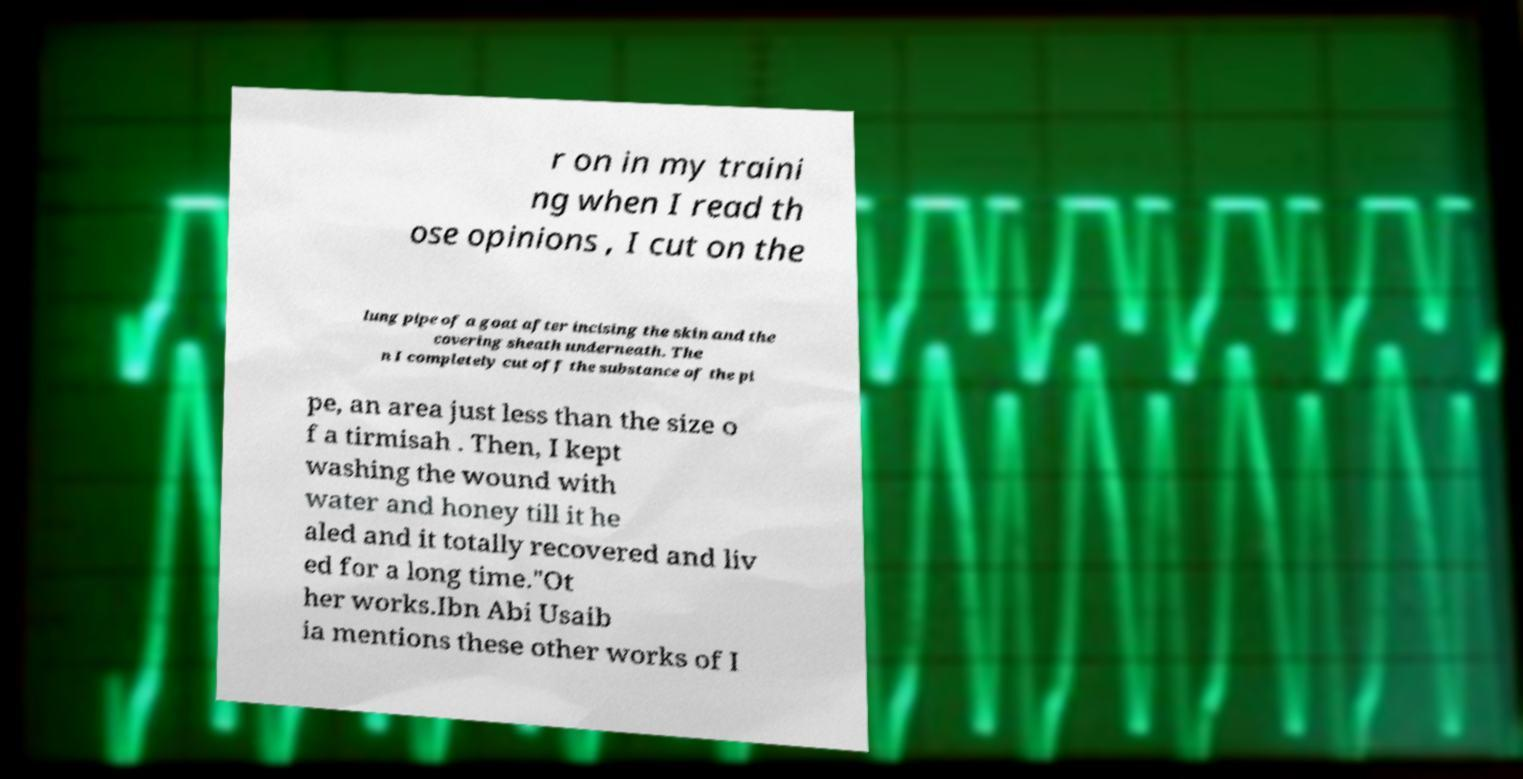Please read and relay the text visible in this image. What does it say? r on in my traini ng when I read th ose opinions , I cut on the lung pipe of a goat after incising the skin and the covering sheath underneath. The n I completely cut off the substance of the pi pe, an area just less than the size o f a tirmisah . Then, I kept washing the wound with water and honey till it he aled and it totally recovered and liv ed for a long time."Ot her works.Ibn Abi Usaib ia mentions these other works of I 